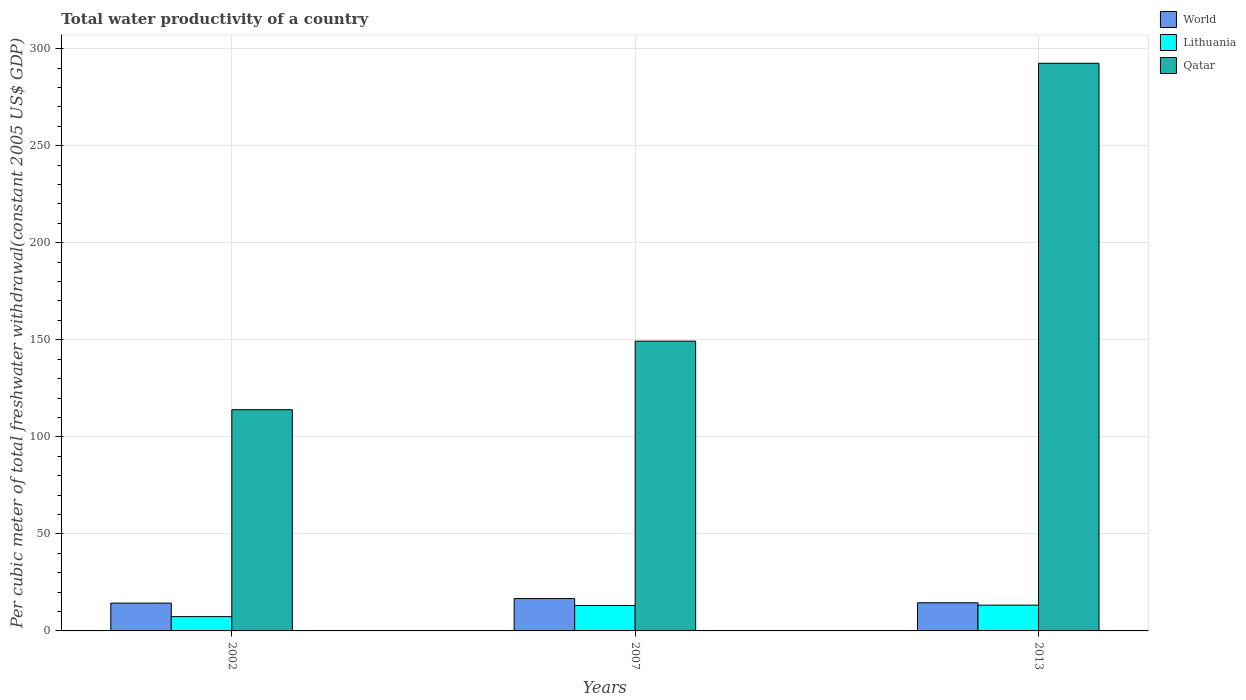How many groups of bars are there?
Offer a terse response. 3. Are the number of bars per tick equal to the number of legend labels?
Offer a very short reply. Yes. Are the number of bars on each tick of the X-axis equal?
Your response must be concise. Yes. How many bars are there on the 2nd tick from the left?
Provide a succinct answer. 3. In how many cases, is the number of bars for a given year not equal to the number of legend labels?
Give a very brief answer. 0. What is the total water productivity in Lithuania in 2013?
Ensure brevity in your answer.  13.28. Across all years, what is the maximum total water productivity in Qatar?
Provide a succinct answer. 292.5. Across all years, what is the minimum total water productivity in Qatar?
Your response must be concise. 113.99. In which year was the total water productivity in Lithuania maximum?
Keep it short and to the point. 2013. In which year was the total water productivity in Lithuania minimum?
Provide a short and direct response. 2002. What is the total total water productivity in Lithuania in the graph?
Provide a succinct answer. 33.75. What is the difference between the total water productivity in Qatar in 2007 and that in 2013?
Offer a terse response. -143.2. What is the difference between the total water productivity in World in 2007 and the total water productivity in Lithuania in 2002?
Give a very brief answer. 9.31. What is the average total water productivity in Lithuania per year?
Provide a short and direct response. 11.25. In the year 2007, what is the difference between the total water productivity in World and total water productivity in Lithuania?
Ensure brevity in your answer.  3.56. What is the ratio of the total water productivity in World in 2002 to that in 2013?
Ensure brevity in your answer.  0.99. Is the total water productivity in Lithuania in 2007 less than that in 2013?
Your response must be concise. Yes. Is the difference between the total water productivity in World in 2002 and 2013 greater than the difference between the total water productivity in Lithuania in 2002 and 2013?
Keep it short and to the point. Yes. What is the difference between the highest and the second highest total water productivity in Qatar?
Keep it short and to the point. 143.2. What is the difference between the highest and the lowest total water productivity in World?
Keep it short and to the point. 2.33. In how many years, is the total water productivity in Lithuania greater than the average total water productivity in Lithuania taken over all years?
Offer a terse response. 2. What does the 3rd bar from the left in 2002 represents?
Provide a succinct answer. Qatar. What does the 2nd bar from the right in 2002 represents?
Your response must be concise. Lithuania. Is it the case that in every year, the sum of the total water productivity in Qatar and total water productivity in World is greater than the total water productivity in Lithuania?
Give a very brief answer. Yes. Are all the bars in the graph horizontal?
Offer a very short reply. No. What is the difference between two consecutive major ticks on the Y-axis?
Make the answer very short. 50. Are the values on the major ticks of Y-axis written in scientific E-notation?
Your answer should be very brief. No. Does the graph contain any zero values?
Offer a terse response. No. Where does the legend appear in the graph?
Provide a short and direct response. Top right. How many legend labels are there?
Make the answer very short. 3. What is the title of the graph?
Provide a short and direct response. Total water productivity of a country. Does "East Asia (all income levels)" appear as one of the legend labels in the graph?
Your answer should be very brief. No. What is the label or title of the X-axis?
Make the answer very short. Years. What is the label or title of the Y-axis?
Provide a short and direct response. Per cubic meter of total freshwater withdrawal(constant 2005 US$ GDP). What is the Per cubic meter of total freshwater withdrawal(constant 2005 US$ GDP) of World in 2002?
Your response must be concise. 14.34. What is the Per cubic meter of total freshwater withdrawal(constant 2005 US$ GDP) in Lithuania in 2002?
Ensure brevity in your answer.  7.36. What is the Per cubic meter of total freshwater withdrawal(constant 2005 US$ GDP) of Qatar in 2002?
Offer a very short reply. 113.99. What is the Per cubic meter of total freshwater withdrawal(constant 2005 US$ GDP) of World in 2007?
Your answer should be compact. 16.67. What is the Per cubic meter of total freshwater withdrawal(constant 2005 US$ GDP) of Lithuania in 2007?
Offer a very short reply. 13.11. What is the Per cubic meter of total freshwater withdrawal(constant 2005 US$ GDP) of Qatar in 2007?
Your response must be concise. 149.3. What is the Per cubic meter of total freshwater withdrawal(constant 2005 US$ GDP) of World in 2013?
Your answer should be very brief. 14.51. What is the Per cubic meter of total freshwater withdrawal(constant 2005 US$ GDP) in Lithuania in 2013?
Your response must be concise. 13.28. What is the Per cubic meter of total freshwater withdrawal(constant 2005 US$ GDP) of Qatar in 2013?
Offer a very short reply. 292.5. Across all years, what is the maximum Per cubic meter of total freshwater withdrawal(constant 2005 US$ GDP) of World?
Offer a terse response. 16.67. Across all years, what is the maximum Per cubic meter of total freshwater withdrawal(constant 2005 US$ GDP) in Lithuania?
Your response must be concise. 13.28. Across all years, what is the maximum Per cubic meter of total freshwater withdrawal(constant 2005 US$ GDP) in Qatar?
Keep it short and to the point. 292.5. Across all years, what is the minimum Per cubic meter of total freshwater withdrawal(constant 2005 US$ GDP) of World?
Make the answer very short. 14.34. Across all years, what is the minimum Per cubic meter of total freshwater withdrawal(constant 2005 US$ GDP) in Lithuania?
Give a very brief answer. 7.36. Across all years, what is the minimum Per cubic meter of total freshwater withdrawal(constant 2005 US$ GDP) in Qatar?
Give a very brief answer. 113.99. What is the total Per cubic meter of total freshwater withdrawal(constant 2005 US$ GDP) in World in the graph?
Give a very brief answer. 45.52. What is the total Per cubic meter of total freshwater withdrawal(constant 2005 US$ GDP) of Lithuania in the graph?
Give a very brief answer. 33.75. What is the total Per cubic meter of total freshwater withdrawal(constant 2005 US$ GDP) of Qatar in the graph?
Give a very brief answer. 555.79. What is the difference between the Per cubic meter of total freshwater withdrawal(constant 2005 US$ GDP) of World in 2002 and that in 2007?
Keep it short and to the point. -2.33. What is the difference between the Per cubic meter of total freshwater withdrawal(constant 2005 US$ GDP) in Lithuania in 2002 and that in 2007?
Provide a succinct answer. -5.75. What is the difference between the Per cubic meter of total freshwater withdrawal(constant 2005 US$ GDP) of Qatar in 2002 and that in 2007?
Give a very brief answer. -35.31. What is the difference between the Per cubic meter of total freshwater withdrawal(constant 2005 US$ GDP) in World in 2002 and that in 2013?
Provide a succinct answer. -0.16. What is the difference between the Per cubic meter of total freshwater withdrawal(constant 2005 US$ GDP) of Lithuania in 2002 and that in 2013?
Provide a short and direct response. -5.92. What is the difference between the Per cubic meter of total freshwater withdrawal(constant 2005 US$ GDP) in Qatar in 2002 and that in 2013?
Your answer should be very brief. -178.5. What is the difference between the Per cubic meter of total freshwater withdrawal(constant 2005 US$ GDP) in World in 2007 and that in 2013?
Provide a short and direct response. 2.16. What is the difference between the Per cubic meter of total freshwater withdrawal(constant 2005 US$ GDP) in Lithuania in 2007 and that in 2013?
Your answer should be very brief. -0.17. What is the difference between the Per cubic meter of total freshwater withdrawal(constant 2005 US$ GDP) of Qatar in 2007 and that in 2013?
Ensure brevity in your answer.  -143.2. What is the difference between the Per cubic meter of total freshwater withdrawal(constant 2005 US$ GDP) of World in 2002 and the Per cubic meter of total freshwater withdrawal(constant 2005 US$ GDP) of Lithuania in 2007?
Your answer should be very brief. 1.24. What is the difference between the Per cubic meter of total freshwater withdrawal(constant 2005 US$ GDP) in World in 2002 and the Per cubic meter of total freshwater withdrawal(constant 2005 US$ GDP) in Qatar in 2007?
Your answer should be very brief. -134.96. What is the difference between the Per cubic meter of total freshwater withdrawal(constant 2005 US$ GDP) in Lithuania in 2002 and the Per cubic meter of total freshwater withdrawal(constant 2005 US$ GDP) in Qatar in 2007?
Your response must be concise. -141.94. What is the difference between the Per cubic meter of total freshwater withdrawal(constant 2005 US$ GDP) in World in 2002 and the Per cubic meter of total freshwater withdrawal(constant 2005 US$ GDP) in Lithuania in 2013?
Give a very brief answer. 1.06. What is the difference between the Per cubic meter of total freshwater withdrawal(constant 2005 US$ GDP) in World in 2002 and the Per cubic meter of total freshwater withdrawal(constant 2005 US$ GDP) in Qatar in 2013?
Give a very brief answer. -278.15. What is the difference between the Per cubic meter of total freshwater withdrawal(constant 2005 US$ GDP) of Lithuania in 2002 and the Per cubic meter of total freshwater withdrawal(constant 2005 US$ GDP) of Qatar in 2013?
Your response must be concise. -285.14. What is the difference between the Per cubic meter of total freshwater withdrawal(constant 2005 US$ GDP) of World in 2007 and the Per cubic meter of total freshwater withdrawal(constant 2005 US$ GDP) of Lithuania in 2013?
Give a very brief answer. 3.39. What is the difference between the Per cubic meter of total freshwater withdrawal(constant 2005 US$ GDP) of World in 2007 and the Per cubic meter of total freshwater withdrawal(constant 2005 US$ GDP) of Qatar in 2013?
Your response must be concise. -275.83. What is the difference between the Per cubic meter of total freshwater withdrawal(constant 2005 US$ GDP) in Lithuania in 2007 and the Per cubic meter of total freshwater withdrawal(constant 2005 US$ GDP) in Qatar in 2013?
Offer a very short reply. -279.39. What is the average Per cubic meter of total freshwater withdrawal(constant 2005 US$ GDP) of World per year?
Your answer should be very brief. 15.17. What is the average Per cubic meter of total freshwater withdrawal(constant 2005 US$ GDP) of Lithuania per year?
Keep it short and to the point. 11.25. What is the average Per cubic meter of total freshwater withdrawal(constant 2005 US$ GDP) in Qatar per year?
Offer a very short reply. 185.26. In the year 2002, what is the difference between the Per cubic meter of total freshwater withdrawal(constant 2005 US$ GDP) in World and Per cubic meter of total freshwater withdrawal(constant 2005 US$ GDP) in Lithuania?
Your response must be concise. 6.98. In the year 2002, what is the difference between the Per cubic meter of total freshwater withdrawal(constant 2005 US$ GDP) in World and Per cubic meter of total freshwater withdrawal(constant 2005 US$ GDP) in Qatar?
Your answer should be compact. -99.65. In the year 2002, what is the difference between the Per cubic meter of total freshwater withdrawal(constant 2005 US$ GDP) of Lithuania and Per cubic meter of total freshwater withdrawal(constant 2005 US$ GDP) of Qatar?
Provide a succinct answer. -106.63. In the year 2007, what is the difference between the Per cubic meter of total freshwater withdrawal(constant 2005 US$ GDP) of World and Per cubic meter of total freshwater withdrawal(constant 2005 US$ GDP) of Lithuania?
Give a very brief answer. 3.56. In the year 2007, what is the difference between the Per cubic meter of total freshwater withdrawal(constant 2005 US$ GDP) in World and Per cubic meter of total freshwater withdrawal(constant 2005 US$ GDP) in Qatar?
Ensure brevity in your answer.  -132.63. In the year 2007, what is the difference between the Per cubic meter of total freshwater withdrawal(constant 2005 US$ GDP) in Lithuania and Per cubic meter of total freshwater withdrawal(constant 2005 US$ GDP) in Qatar?
Offer a terse response. -136.19. In the year 2013, what is the difference between the Per cubic meter of total freshwater withdrawal(constant 2005 US$ GDP) of World and Per cubic meter of total freshwater withdrawal(constant 2005 US$ GDP) of Lithuania?
Offer a very short reply. 1.23. In the year 2013, what is the difference between the Per cubic meter of total freshwater withdrawal(constant 2005 US$ GDP) in World and Per cubic meter of total freshwater withdrawal(constant 2005 US$ GDP) in Qatar?
Provide a succinct answer. -277.99. In the year 2013, what is the difference between the Per cubic meter of total freshwater withdrawal(constant 2005 US$ GDP) of Lithuania and Per cubic meter of total freshwater withdrawal(constant 2005 US$ GDP) of Qatar?
Your answer should be compact. -279.22. What is the ratio of the Per cubic meter of total freshwater withdrawal(constant 2005 US$ GDP) of World in 2002 to that in 2007?
Ensure brevity in your answer.  0.86. What is the ratio of the Per cubic meter of total freshwater withdrawal(constant 2005 US$ GDP) of Lithuania in 2002 to that in 2007?
Your response must be concise. 0.56. What is the ratio of the Per cubic meter of total freshwater withdrawal(constant 2005 US$ GDP) in Qatar in 2002 to that in 2007?
Provide a succinct answer. 0.76. What is the ratio of the Per cubic meter of total freshwater withdrawal(constant 2005 US$ GDP) in World in 2002 to that in 2013?
Keep it short and to the point. 0.99. What is the ratio of the Per cubic meter of total freshwater withdrawal(constant 2005 US$ GDP) of Lithuania in 2002 to that in 2013?
Offer a very short reply. 0.55. What is the ratio of the Per cubic meter of total freshwater withdrawal(constant 2005 US$ GDP) in Qatar in 2002 to that in 2013?
Provide a succinct answer. 0.39. What is the ratio of the Per cubic meter of total freshwater withdrawal(constant 2005 US$ GDP) in World in 2007 to that in 2013?
Offer a very short reply. 1.15. What is the ratio of the Per cubic meter of total freshwater withdrawal(constant 2005 US$ GDP) in Lithuania in 2007 to that in 2013?
Your answer should be very brief. 0.99. What is the ratio of the Per cubic meter of total freshwater withdrawal(constant 2005 US$ GDP) in Qatar in 2007 to that in 2013?
Provide a succinct answer. 0.51. What is the difference between the highest and the second highest Per cubic meter of total freshwater withdrawal(constant 2005 US$ GDP) in World?
Make the answer very short. 2.16. What is the difference between the highest and the second highest Per cubic meter of total freshwater withdrawal(constant 2005 US$ GDP) in Lithuania?
Offer a terse response. 0.17. What is the difference between the highest and the second highest Per cubic meter of total freshwater withdrawal(constant 2005 US$ GDP) in Qatar?
Keep it short and to the point. 143.2. What is the difference between the highest and the lowest Per cubic meter of total freshwater withdrawal(constant 2005 US$ GDP) in World?
Keep it short and to the point. 2.33. What is the difference between the highest and the lowest Per cubic meter of total freshwater withdrawal(constant 2005 US$ GDP) in Lithuania?
Provide a short and direct response. 5.92. What is the difference between the highest and the lowest Per cubic meter of total freshwater withdrawal(constant 2005 US$ GDP) in Qatar?
Your answer should be very brief. 178.5. 